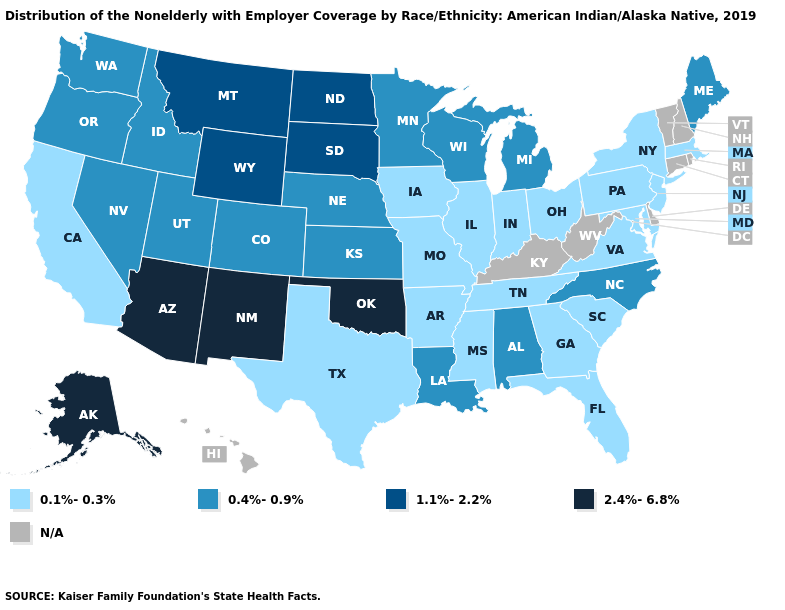What is the value of Illinois?
Short answer required. 0.1%-0.3%. Name the states that have a value in the range 2.4%-6.8%?
Give a very brief answer. Alaska, Arizona, New Mexico, Oklahoma. Is the legend a continuous bar?
Give a very brief answer. No. What is the lowest value in states that border Michigan?
Keep it brief. 0.1%-0.3%. Which states hav the highest value in the MidWest?
Be succinct. North Dakota, South Dakota. Does Alaska have the highest value in the USA?
Quick response, please. Yes. Name the states that have a value in the range 1.1%-2.2%?
Give a very brief answer. Montana, North Dakota, South Dakota, Wyoming. Does New York have the highest value in the Northeast?
Be succinct. No. What is the lowest value in the Northeast?
Write a very short answer. 0.1%-0.3%. Among the states that border West Virginia , which have the lowest value?
Concise answer only. Maryland, Ohio, Pennsylvania, Virginia. Among the states that border Louisiana , which have the lowest value?
Short answer required. Arkansas, Mississippi, Texas. Is the legend a continuous bar?
Give a very brief answer. No. Name the states that have a value in the range 0.4%-0.9%?
Give a very brief answer. Alabama, Colorado, Idaho, Kansas, Louisiana, Maine, Michigan, Minnesota, Nebraska, Nevada, North Carolina, Oregon, Utah, Washington, Wisconsin. What is the lowest value in the MidWest?
Quick response, please. 0.1%-0.3%. 